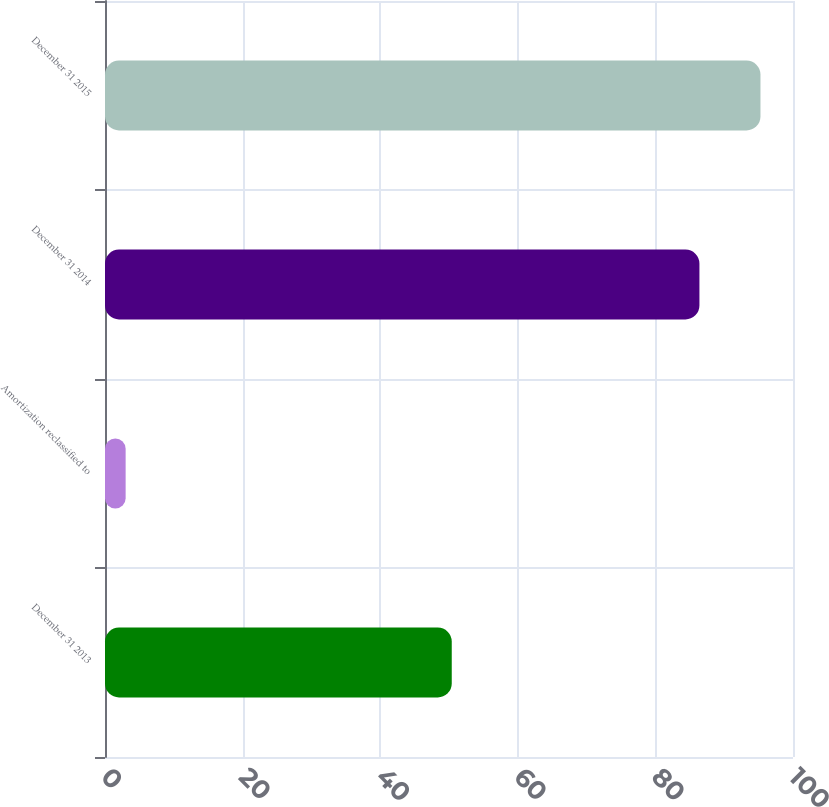<chart> <loc_0><loc_0><loc_500><loc_500><bar_chart><fcel>December 31 2013<fcel>Amortization reclassified to<fcel>December 31 2014<fcel>December 31 2015<nl><fcel>50.4<fcel>3<fcel>86.4<fcel>95.27<nl></chart> 